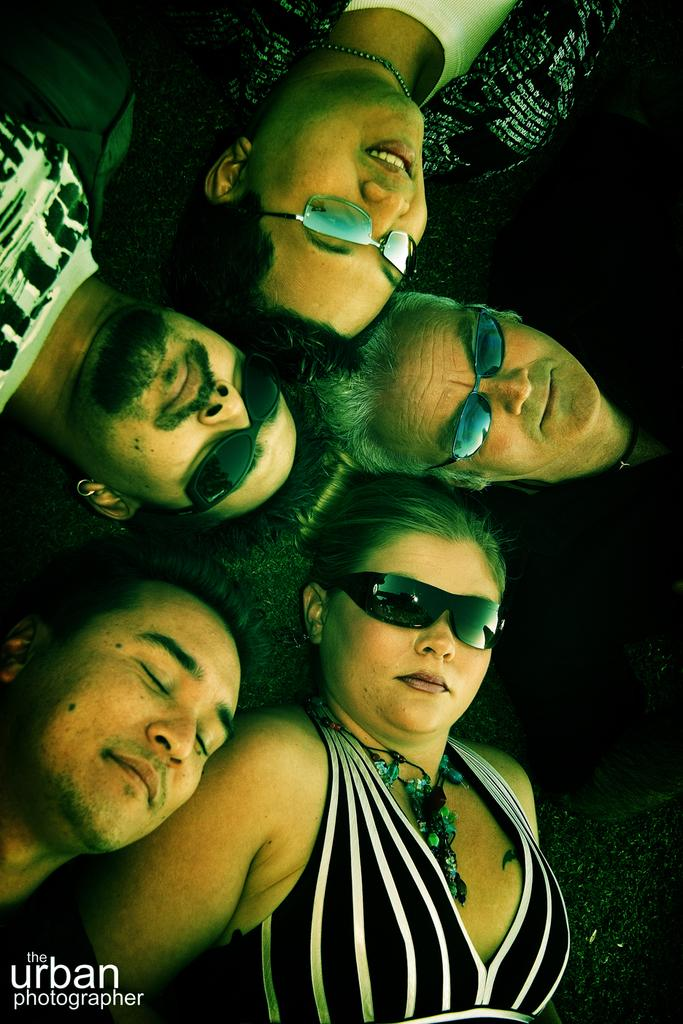What is happening with the group of people in the image? The people are lying on the ground in the image. Are the people wearing any specific accessories? Some of the people are wearing goggles. Is there any text present in the image? Yes, there is some text present at the bottom of the image. What type of drain can be seen in the image? There is no drain present in the image. How does the channel affect the people in the image? There is no channel present in the image. 